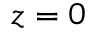Convert formula to latex. <formula><loc_0><loc_0><loc_500><loc_500>z = 0</formula> 